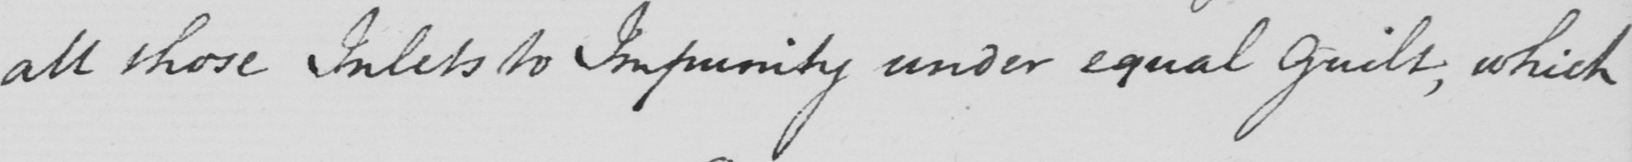Please provide the text content of this handwritten line. all those Inlets to Impunity under equal guilt , which 